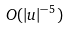Convert formula to latex. <formula><loc_0><loc_0><loc_500><loc_500>O ( | u | ^ { - 5 } )</formula> 